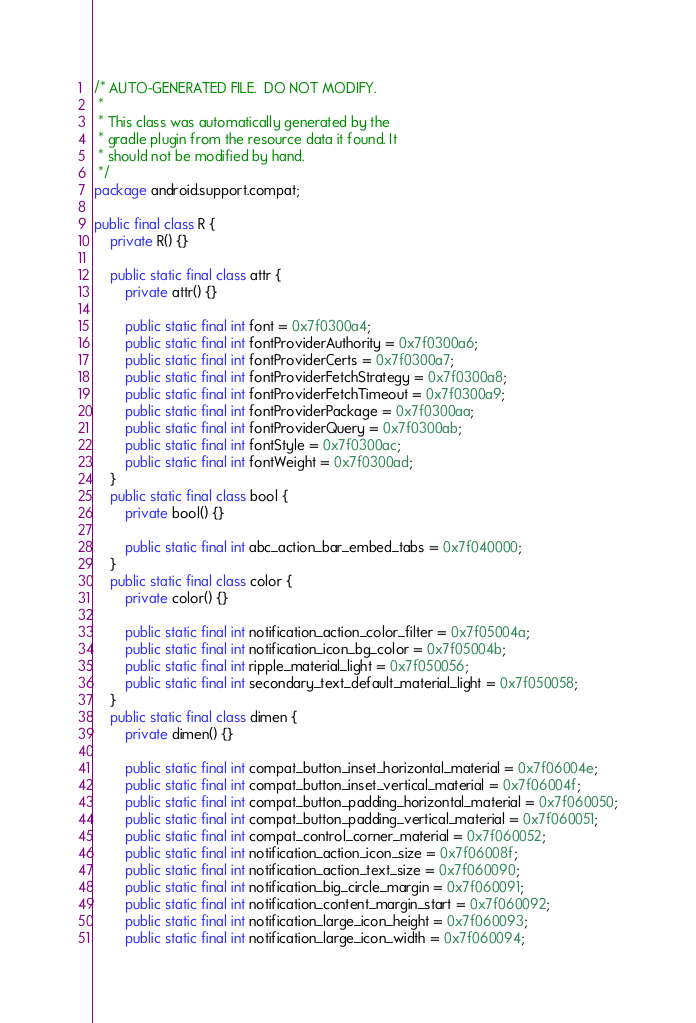Convert code to text. <code><loc_0><loc_0><loc_500><loc_500><_Java_>/* AUTO-GENERATED FILE.  DO NOT MODIFY.
 *
 * This class was automatically generated by the
 * gradle plugin from the resource data it found. It
 * should not be modified by hand.
 */
package android.support.compat;

public final class R {
    private R() {}

    public static final class attr {
        private attr() {}

        public static final int font = 0x7f0300a4;
        public static final int fontProviderAuthority = 0x7f0300a6;
        public static final int fontProviderCerts = 0x7f0300a7;
        public static final int fontProviderFetchStrategy = 0x7f0300a8;
        public static final int fontProviderFetchTimeout = 0x7f0300a9;
        public static final int fontProviderPackage = 0x7f0300aa;
        public static final int fontProviderQuery = 0x7f0300ab;
        public static final int fontStyle = 0x7f0300ac;
        public static final int fontWeight = 0x7f0300ad;
    }
    public static final class bool {
        private bool() {}

        public static final int abc_action_bar_embed_tabs = 0x7f040000;
    }
    public static final class color {
        private color() {}

        public static final int notification_action_color_filter = 0x7f05004a;
        public static final int notification_icon_bg_color = 0x7f05004b;
        public static final int ripple_material_light = 0x7f050056;
        public static final int secondary_text_default_material_light = 0x7f050058;
    }
    public static final class dimen {
        private dimen() {}

        public static final int compat_button_inset_horizontal_material = 0x7f06004e;
        public static final int compat_button_inset_vertical_material = 0x7f06004f;
        public static final int compat_button_padding_horizontal_material = 0x7f060050;
        public static final int compat_button_padding_vertical_material = 0x7f060051;
        public static final int compat_control_corner_material = 0x7f060052;
        public static final int notification_action_icon_size = 0x7f06008f;
        public static final int notification_action_text_size = 0x7f060090;
        public static final int notification_big_circle_margin = 0x7f060091;
        public static final int notification_content_margin_start = 0x7f060092;
        public static final int notification_large_icon_height = 0x7f060093;
        public static final int notification_large_icon_width = 0x7f060094;</code> 